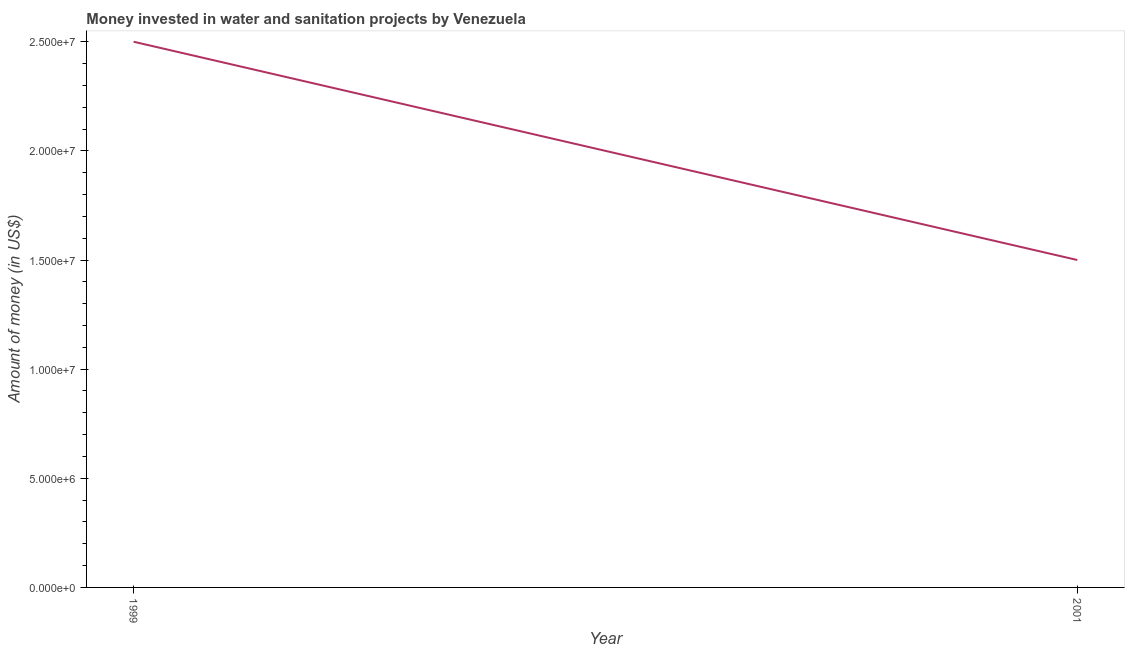What is the investment in 2001?
Offer a terse response. 1.50e+07. Across all years, what is the maximum investment?
Offer a very short reply. 2.50e+07. Across all years, what is the minimum investment?
Your answer should be very brief. 1.50e+07. In which year was the investment minimum?
Your answer should be compact. 2001. What is the sum of the investment?
Make the answer very short. 4.00e+07. What is the difference between the investment in 1999 and 2001?
Provide a short and direct response. 1.00e+07. In how many years, is the investment greater than 12000000 US$?
Provide a short and direct response. 2. Do a majority of the years between 2001 and 1999 (inclusive) have investment greater than 1000000 US$?
Give a very brief answer. No. What is the ratio of the investment in 1999 to that in 2001?
Your answer should be compact. 1.67. Is the investment in 1999 less than that in 2001?
Your answer should be very brief. No. In how many years, is the investment greater than the average investment taken over all years?
Provide a succinct answer. 1. Does the investment monotonically increase over the years?
Provide a succinct answer. No. What is the difference between two consecutive major ticks on the Y-axis?
Offer a very short reply. 5.00e+06. Are the values on the major ticks of Y-axis written in scientific E-notation?
Provide a succinct answer. Yes. Does the graph contain any zero values?
Provide a succinct answer. No. What is the title of the graph?
Your answer should be compact. Money invested in water and sanitation projects by Venezuela. What is the label or title of the X-axis?
Offer a very short reply. Year. What is the label or title of the Y-axis?
Your answer should be compact. Amount of money (in US$). What is the Amount of money (in US$) of 1999?
Provide a short and direct response. 2.50e+07. What is the Amount of money (in US$) in 2001?
Keep it short and to the point. 1.50e+07. What is the difference between the Amount of money (in US$) in 1999 and 2001?
Provide a short and direct response. 1.00e+07. What is the ratio of the Amount of money (in US$) in 1999 to that in 2001?
Give a very brief answer. 1.67. 